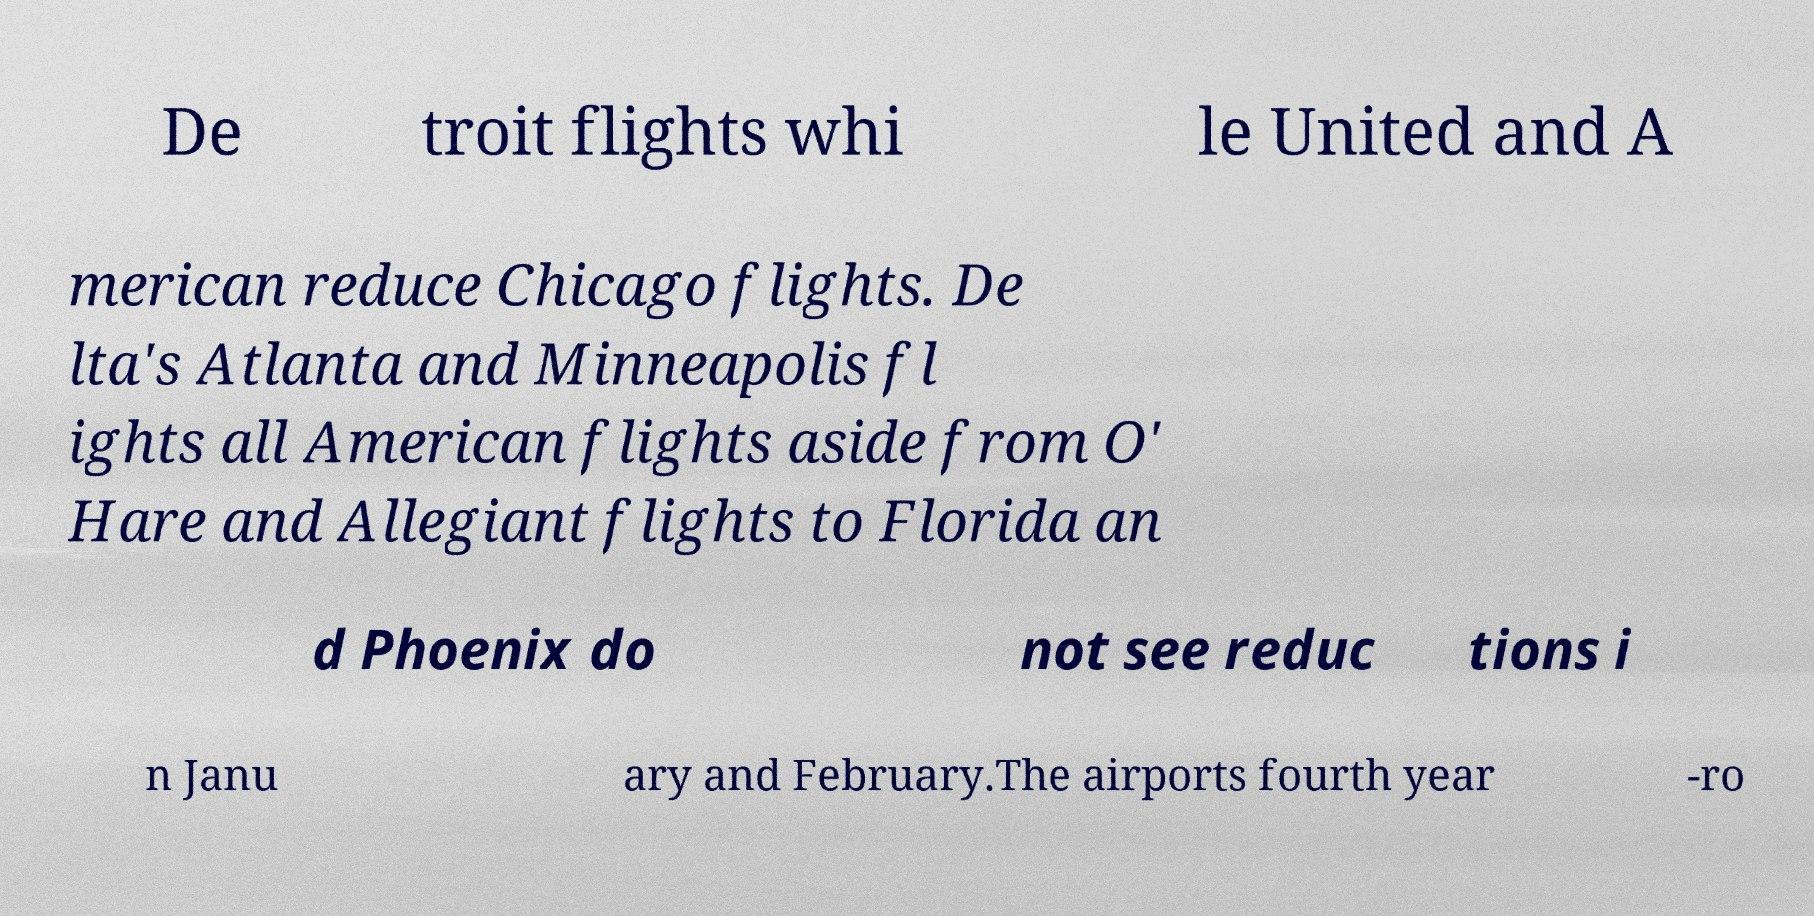Could you extract and type out the text from this image? De troit flights whi le United and A merican reduce Chicago flights. De lta's Atlanta and Minneapolis fl ights all American flights aside from O' Hare and Allegiant flights to Florida an d Phoenix do not see reduc tions i n Janu ary and February.The airports fourth year -ro 